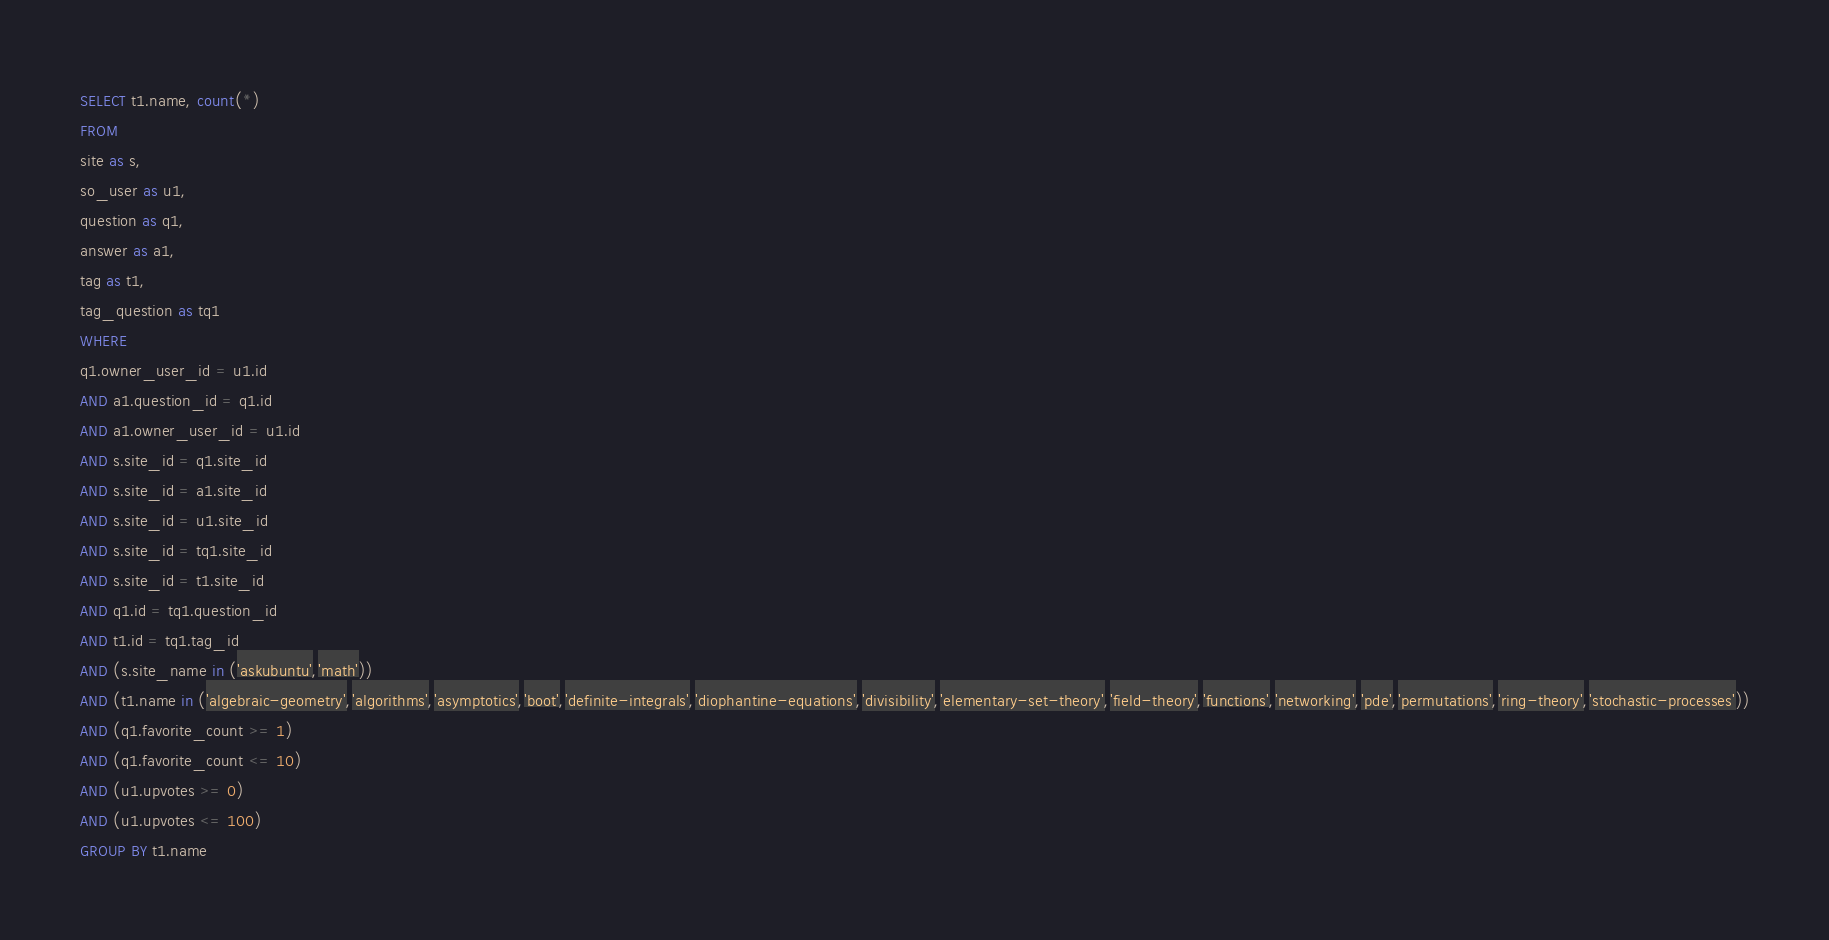Convert code to text. <code><loc_0><loc_0><loc_500><loc_500><_SQL_>SELECT t1.name, count(*)
FROM
site as s,
so_user as u1,
question as q1,
answer as a1,
tag as t1,
tag_question as tq1
WHERE
q1.owner_user_id = u1.id
AND a1.question_id = q1.id
AND a1.owner_user_id = u1.id
AND s.site_id = q1.site_id
AND s.site_id = a1.site_id
AND s.site_id = u1.site_id
AND s.site_id = tq1.site_id
AND s.site_id = t1.site_id
AND q1.id = tq1.question_id
AND t1.id = tq1.tag_id
AND (s.site_name in ('askubuntu','math'))
AND (t1.name in ('algebraic-geometry','algorithms','asymptotics','boot','definite-integrals','diophantine-equations','divisibility','elementary-set-theory','field-theory','functions','networking','pde','permutations','ring-theory','stochastic-processes'))
AND (q1.favorite_count >= 1)
AND (q1.favorite_count <= 10)
AND (u1.upvotes >= 0)
AND (u1.upvotes <= 100)
GROUP BY t1.name</code> 